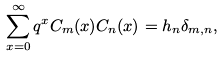<formula> <loc_0><loc_0><loc_500><loc_500>\sum _ { x = 0 } ^ { \infty } q ^ { x } C _ { m } ( x ) C _ { n } ( x ) = h _ { n } \delta _ { m , n } ,</formula> 